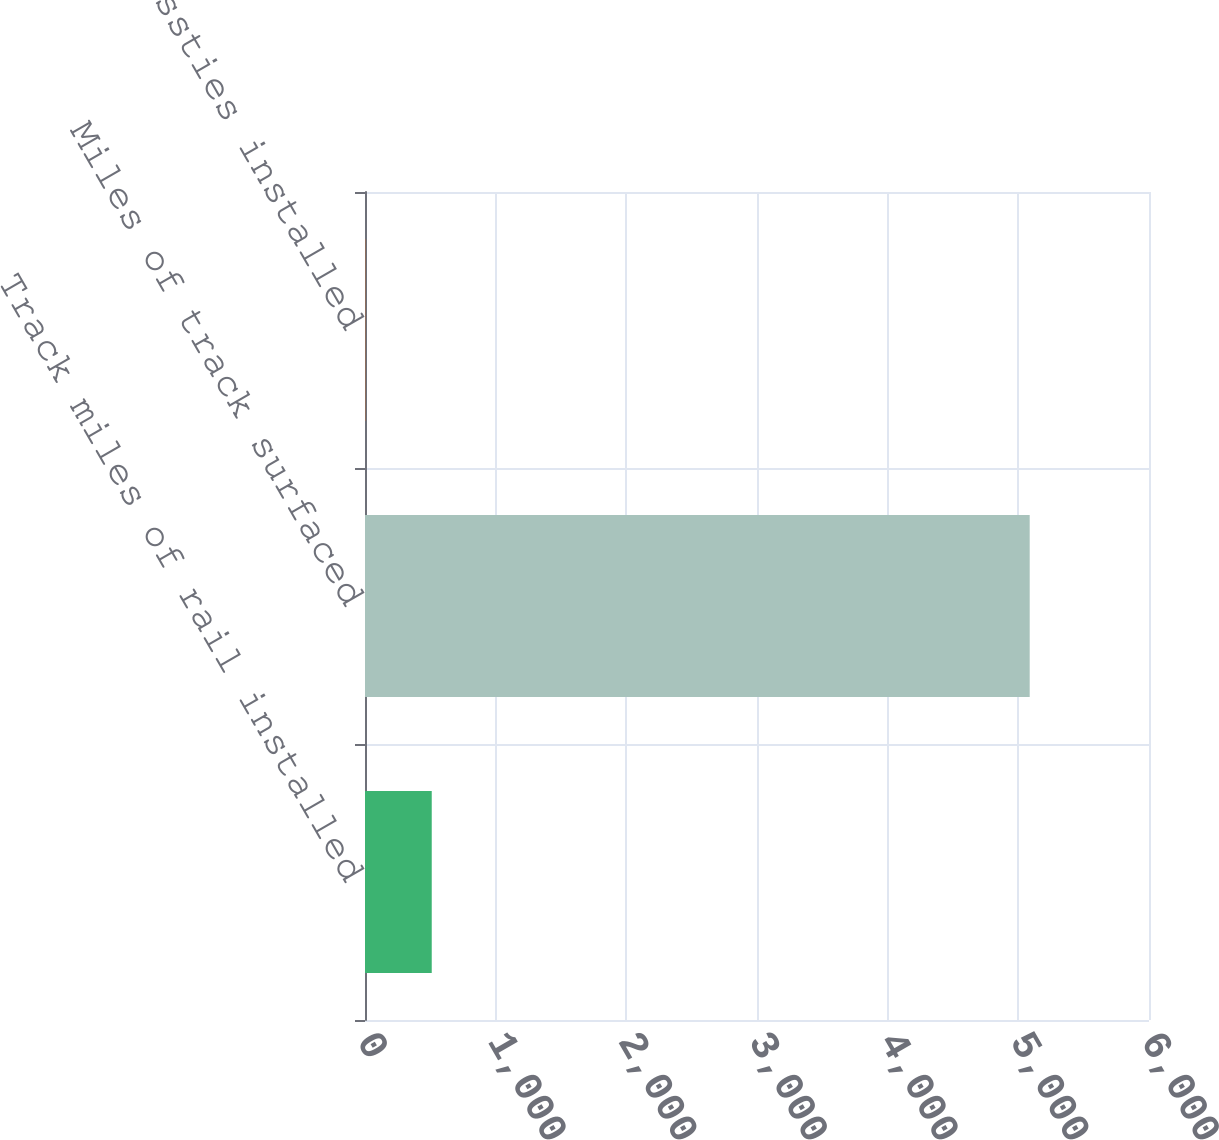<chart> <loc_0><loc_0><loc_500><loc_500><bar_chart><fcel>Track miles of rail installed<fcel>Miles of track surfaced<fcel>New crossties installed<nl><fcel>510.77<fcel>5087<fcel>2.3<nl></chart> 